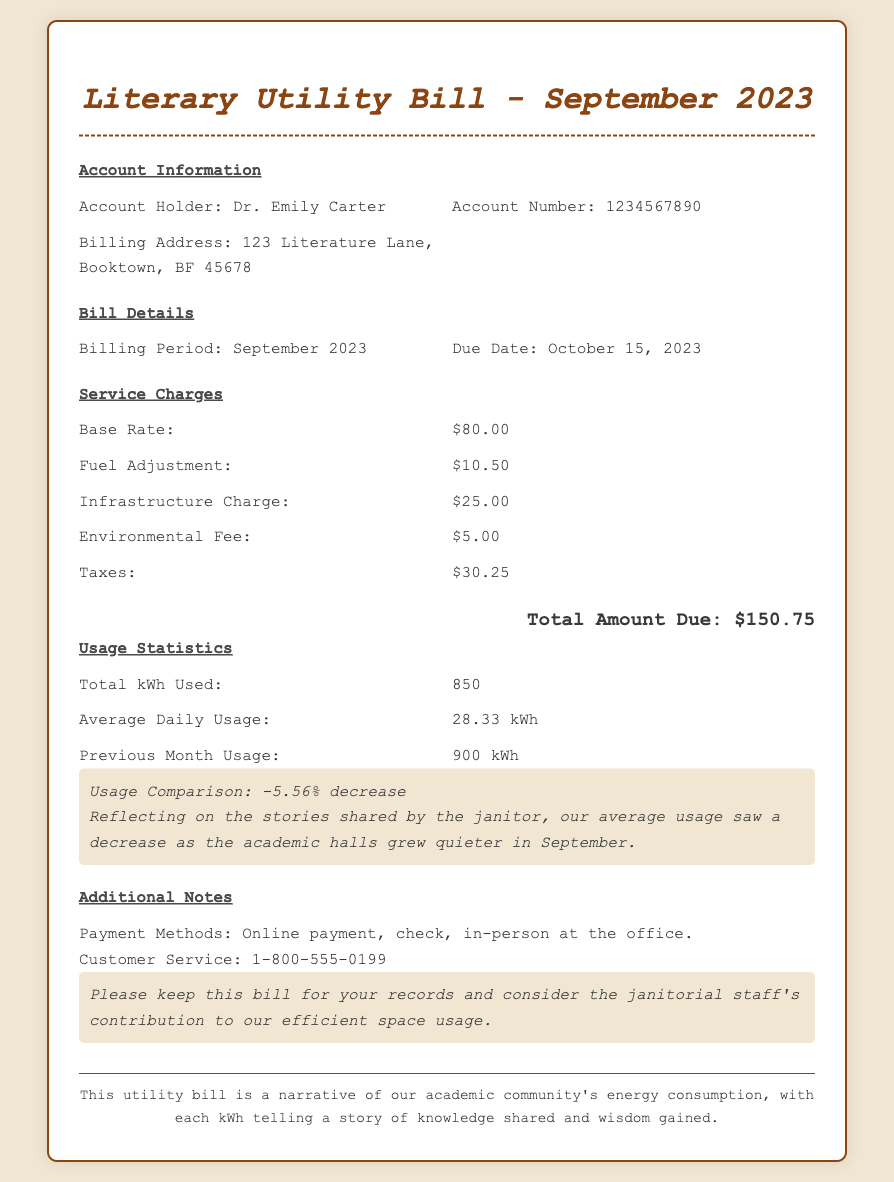What is the account holder's name? The account holder's name is provided in the account information section.
Answer: Dr. Emily Carter What is the total amount due? The total amount due is indicated at the bottom of the bill details section.
Answer: $150.75 What is the billing period? The billing period is specified in the bill details section.
Answer: September 2023 What is the due date for payment? The due date is found alongside the billing period in the bill details section.
Answer: October 15, 2023 What is the base rate charged? The base rate can be found in the service charges breakdown of the document.
Answer: $80.00 How many kilowatt-hours were used in total? The total kWh used is listed in the usage statistics section of the document.
Answer: 850 What was the previous month's usage? Previous month usage is noted in the usage statistics, showing the comparison of energy use.
Answer: 900 kWh What percentage decrease in usage is noted? The usage comparison percentage is included in the usage statistics section.
Answer: -5.56% What payment methods are mentioned? Payment methods are outlined in the additional notes section of the document.
Answer: Online payment, check, in-person at the office What is the customer service phone number? The customer service number is provided in the additional notes section.
Answer: 1-800-555-0199 